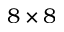Convert formula to latex. <formula><loc_0><loc_0><loc_500><loc_500>8 \times 8</formula> 